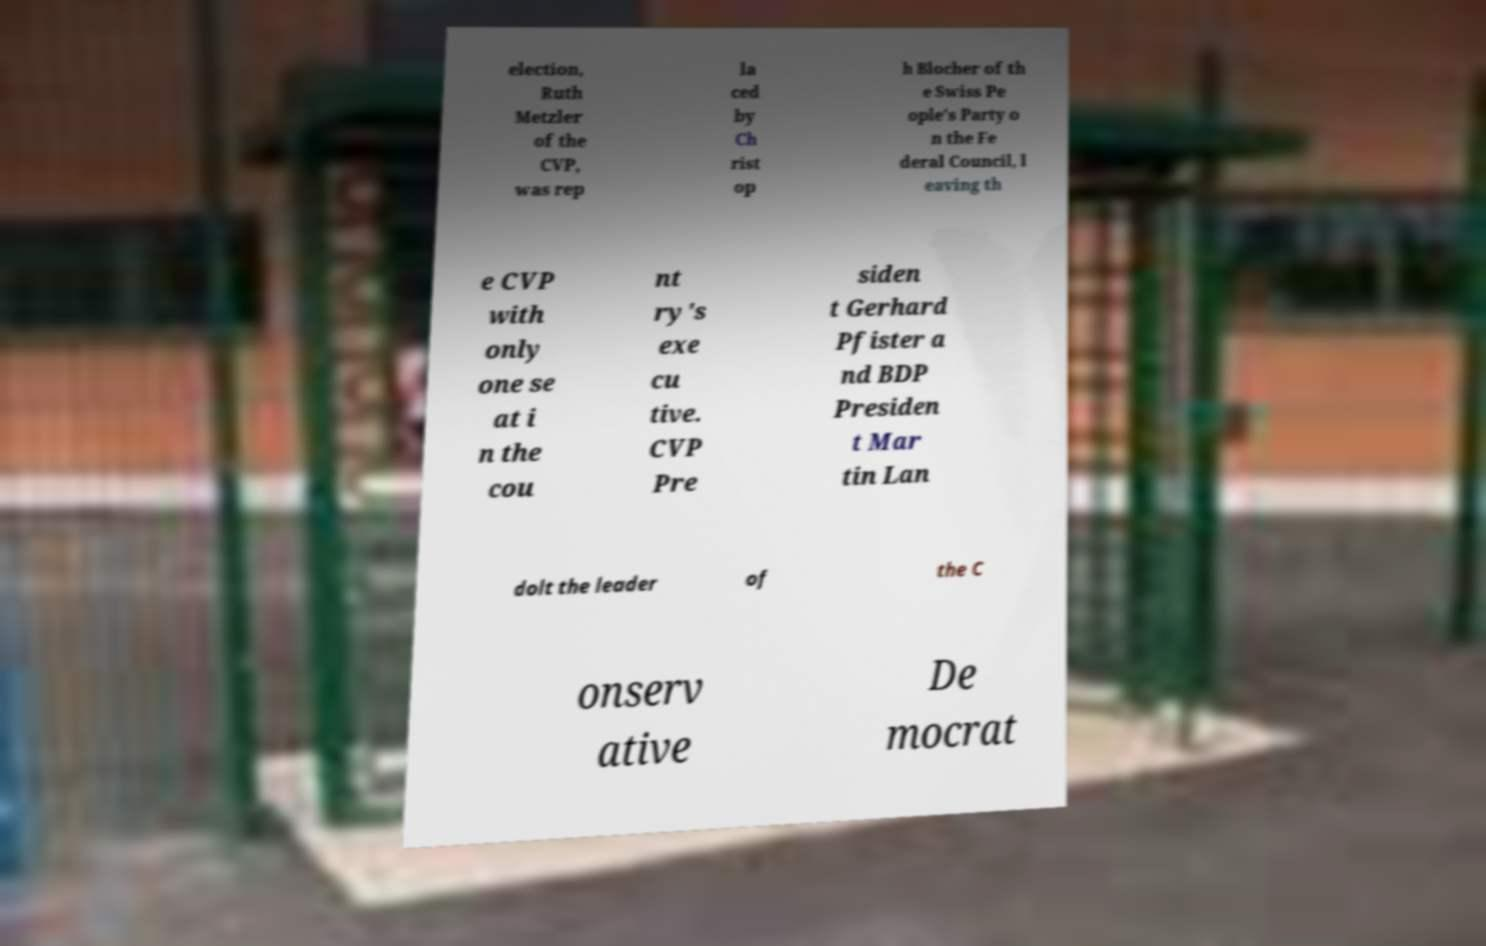There's text embedded in this image that I need extracted. Can you transcribe it verbatim? election, Ruth Metzler of the CVP, was rep la ced by Ch rist op h Blocher of th e Swiss Pe ople's Party o n the Fe deral Council, l eaving th e CVP with only one se at i n the cou nt ry's exe cu tive. CVP Pre siden t Gerhard Pfister a nd BDP Presiden t Mar tin Lan dolt the leader of the C onserv ative De mocrat 